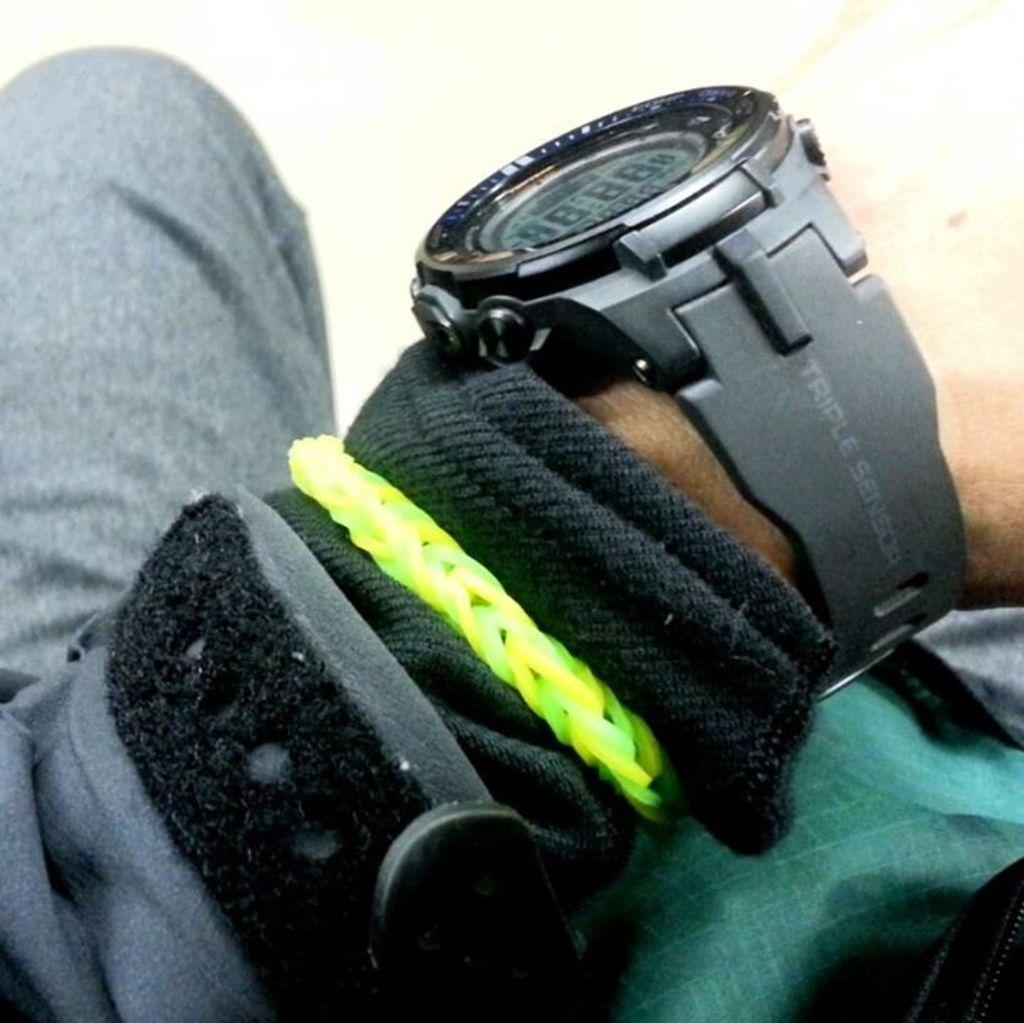<image>
Provide a brief description of the given image. the numbers 8 repeating on a watch someone has 